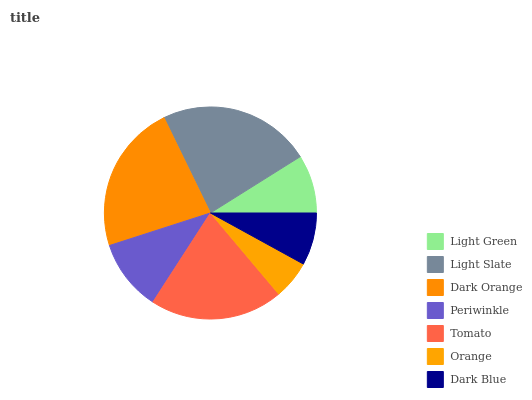Is Orange the minimum?
Answer yes or no. Yes. Is Light Slate the maximum?
Answer yes or no. Yes. Is Dark Orange the minimum?
Answer yes or no. No. Is Dark Orange the maximum?
Answer yes or no. No. Is Light Slate greater than Dark Orange?
Answer yes or no. Yes. Is Dark Orange less than Light Slate?
Answer yes or no. Yes. Is Dark Orange greater than Light Slate?
Answer yes or no. No. Is Light Slate less than Dark Orange?
Answer yes or no. No. Is Periwinkle the high median?
Answer yes or no. Yes. Is Periwinkle the low median?
Answer yes or no. Yes. Is Orange the high median?
Answer yes or no. No. Is Light Slate the low median?
Answer yes or no. No. 